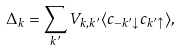<formula> <loc_0><loc_0><loc_500><loc_500>\Delta _ { k } = \sum _ { k ^ { \prime } } V _ { k , k ^ { \prime } } \langle c _ { { - k ^ { \prime } } \downarrow } c _ { { k ^ { \prime } } \uparrow } \rangle ,</formula> 